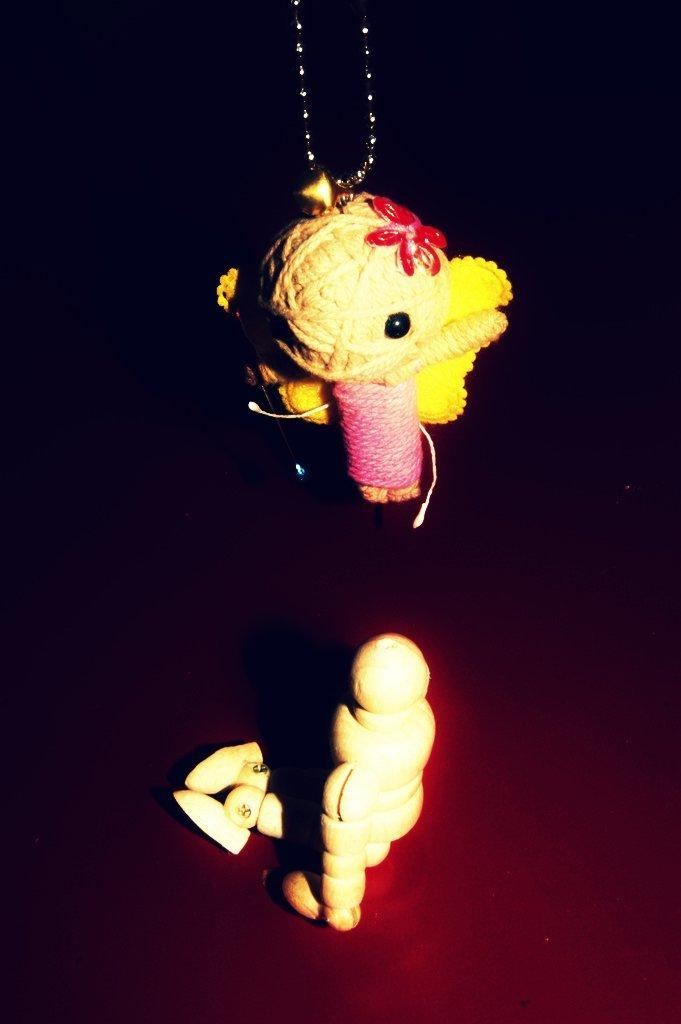What type of jewelry is visible in the image? There is a necklace in the image. How is the necklace depicted in the image? The necklace is truncated towards the top of the image. What other objects can be seen on the surface in the image? There are toys on the surface in the image. What can be observed about the background of the image? The background of the image is dark. How does the glove contribute to the harmony of the image? There is no glove present in the image, so it cannot contribute to the harmony. 